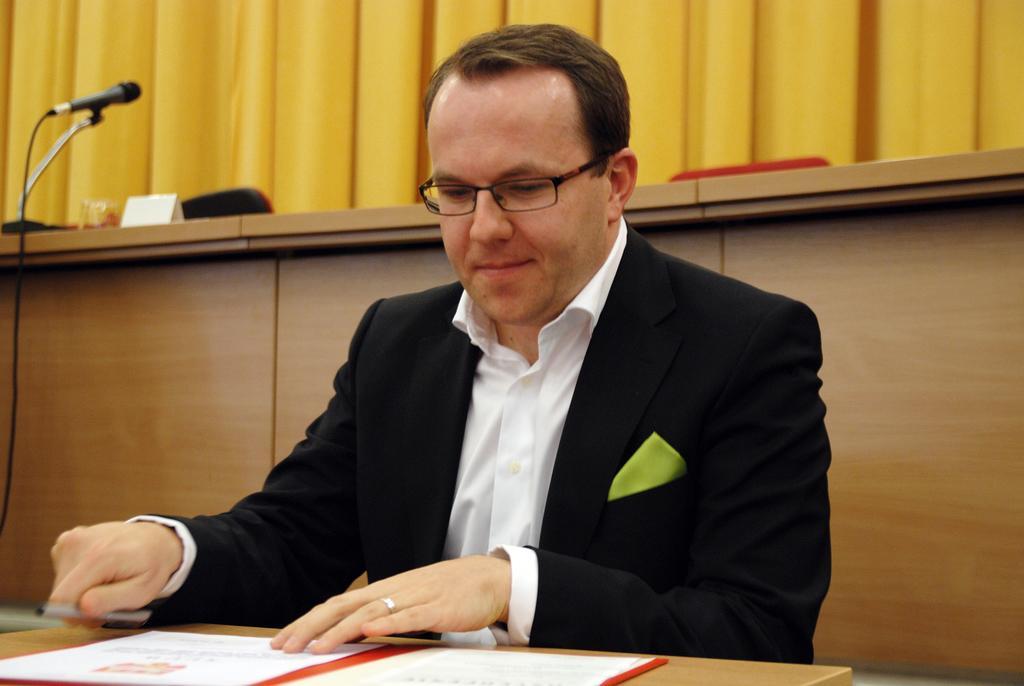Can you describe this image briefly? The person wearing black suit is sitting in front of a table which has an object and a pen on it and there is a mic and yellow color curtain behind him. 